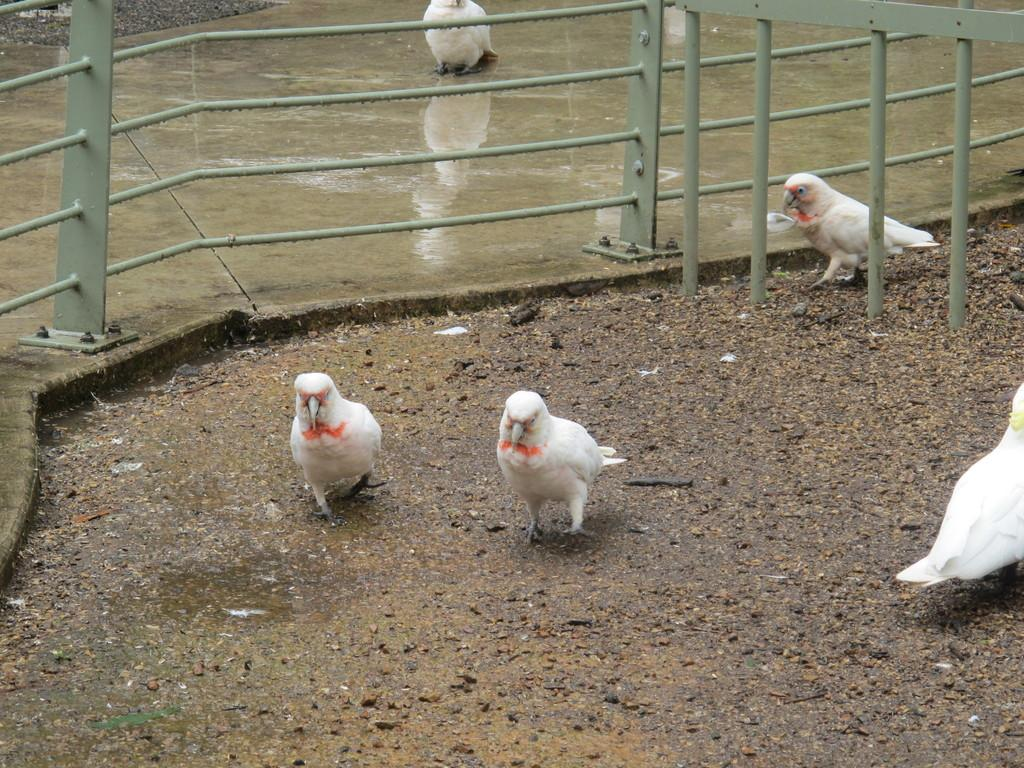What type of animals are in the image? There are parrots in the image. What color are the parrots? The parrots are white in color. Where are the parrots located in the image? The parrots are on a surface. What other object can be seen in the image? There is a railing in the image. How many eggs are being held by the parrots in the image? There are no eggs visible in the image; the parrots are white and on a surface. 